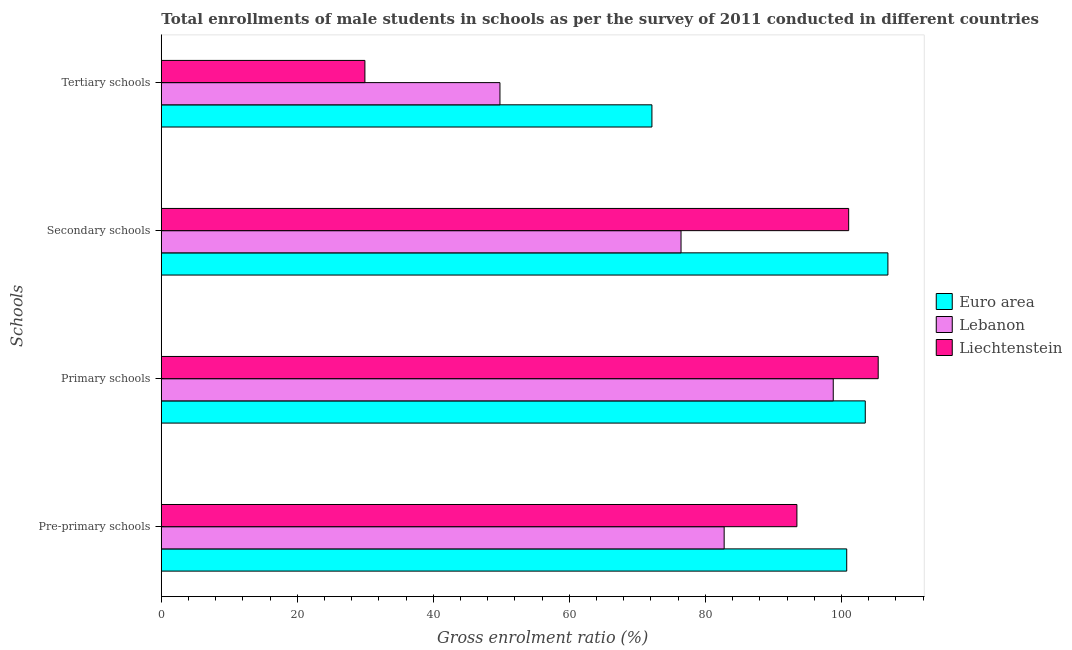How many bars are there on the 1st tick from the bottom?
Your response must be concise. 3. What is the label of the 3rd group of bars from the top?
Provide a succinct answer. Primary schools. What is the gross enrolment ratio(male) in pre-primary schools in Liechtenstein?
Provide a short and direct response. 93.46. Across all countries, what is the maximum gross enrolment ratio(male) in pre-primary schools?
Your answer should be very brief. 100.78. Across all countries, what is the minimum gross enrolment ratio(male) in secondary schools?
Ensure brevity in your answer.  76.42. In which country was the gross enrolment ratio(male) in secondary schools maximum?
Your response must be concise. Euro area. In which country was the gross enrolment ratio(male) in primary schools minimum?
Keep it short and to the point. Lebanon. What is the total gross enrolment ratio(male) in pre-primary schools in the graph?
Offer a terse response. 276.99. What is the difference between the gross enrolment ratio(male) in pre-primary schools in Liechtenstein and that in Euro area?
Your answer should be very brief. -7.32. What is the difference between the gross enrolment ratio(male) in pre-primary schools in Lebanon and the gross enrolment ratio(male) in primary schools in Euro area?
Give a very brief answer. -20.75. What is the average gross enrolment ratio(male) in secondary schools per country?
Your answer should be very brief. 94.77. What is the difference between the gross enrolment ratio(male) in tertiary schools and gross enrolment ratio(male) in pre-primary schools in Liechtenstein?
Your answer should be very brief. -63.52. What is the ratio of the gross enrolment ratio(male) in secondary schools in Euro area to that in Liechtenstein?
Keep it short and to the point. 1.06. Is the gross enrolment ratio(male) in pre-primary schools in Lebanon less than that in Liechtenstein?
Your answer should be very brief. Yes. What is the difference between the highest and the second highest gross enrolment ratio(male) in primary schools?
Your answer should be compact. 1.9. What is the difference between the highest and the lowest gross enrolment ratio(male) in pre-primary schools?
Offer a terse response. 18.02. In how many countries, is the gross enrolment ratio(male) in pre-primary schools greater than the average gross enrolment ratio(male) in pre-primary schools taken over all countries?
Your response must be concise. 2. What does the 1st bar from the top in Pre-primary schools represents?
Ensure brevity in your answer.  Liechtenstein. What does the 1st bar from the bottom in Primary schools represents?
Offer a terse response. Euro area. What is the difference between two consecutive major ticks on the X-axis?
Your response must be concise. 20. Does the graph contain any zero values?
Your answer should be very brief. No. Does the graph contain grids?
Offer a very short reply. No. What is the title of the graph?
Offer a terse response. Total enrollments of male students in schools as per the survey of 2011 conducted in different countries. What is the label or title of the Y-axis?
Make the answer very short. Schools. What is the Gross enrolment ratio (%) in Euro area in Pre-primary schools?
Your answer should be very brief. 100.78. What is the Gross enrolment ratio (%) in Lebanon in Pre-primary schools?
Keep it short and to the point. 82.76. What is the Gross enrolment ratio (%) of Liechtenstein in Pre-primary schools?
Offer a terse response. 93.46. What is the Gross enrolment ratio (%) in Euro area in Primary schools?
Provide a succinct answer. 103.51. What is the Gross enrolment ratio (%) of Lebanon in Primary schools?
Your answer should be compact. 98.8. What is the Gross enrolment ratio (%) of Liechtenstein in Primary schools?
Your answer should be very brief. 105.41. What is the Gross enrolment ratio (%) in Euro area in Secondary schools?
Make the answer very short. 106.84. What is the Gross enrolment ratio (%) of Lebanon in Secondary schools?
Your answer should be compact. 76.42. What is the Gross enrolment ratio (%) of Liechtenstein in Secondary schools?
Give a very brief answer. 101.07. What is the Gross enrolment ratio (%) of Euro area in Tertiary schools?
Keep it short and to the point. 72.14. What is the Gross enrolment ratio (%) in Lebanon in Tertiary schools?
Provide a succinct answer. 49.79. What is the Gross enrolment ratio (%) of Liechtenstein in Tertiary schools?
Offer a terse response. 29.94. Across all Schools, what is the maximum Gross enrolment ratio (%) of Euro area?
Keep it short and to the point. 106.84. Across all Schools, what is the maximum Gross enrolment ratio (%) of Lebanon?
Keep it short and to the point. 98.8. Across all Schools, what is the maximum Gross enrolment ratio (%) in Liechtenstein?
Offer a very short reply. 105.41. Across all Schools, what is the minimum Gross enrolment ratio (%) in Euro area?
Ensure brevity in your answer.  72.14. Across all Schools, what is the minimum Gross enrolment ratio (%) of Lebanon?
Keep it short and to the point. 49.79. Across all Schools, what is the minimum Gross enrolment ratio (%) in Liechtenstein?
Give a very brief answer. 29.94. What is the total Gross enrolment ratio (%) in Euro area in the graph?
Your answer should be compact. 383.26. What is the total Gross enrolment ratio (%) in Lebanon in the graph?
Ensure brevity in your answer.  307.77. What is the total Gross enrolment ratio (%) in Liechtenstein in the graph?
Give a very brief answer. 329.87. What is the difference between the Gross enrolment ratio (%) in Euro area in Pre-primary schools and that in Primary schools?
Keep it short and to the point. -2.73. What is the difference between the Gross enrolment ratio (%) of Lebanon in Pre-primary schools and that in Primary schools?
Offer a very short reply. -16.04. What is the difference between the Gross enrolment ratio (%) of Liechtenstein in Pre-primary schools and that in Primary schools?
Offer a very short reply. -11.95. What is the difference between the Gross enrolment ratio (%) of Euro area in Pre-primary schools and that in Secondary schools?
Provide a succinct answer. -6.06. What is the difference between the Gross enrolment ratio (%) of Lebanon in Pre-primary schools and that in Secondary schools?
Keep it short and to the point. 6.34. What is the difference between the Gross enrolment ratio (%) of Liechtenstein in Pre-primary schools and that in Secondary schools?
Your response must be concise. -7.61. What is the difference between the Gross enrolment ratio (%) of Euro area in Pre-primary schools and that in Tertiary schools?
Your answer should be compact. 28.64. What is the difference between the Gross enrolment ratio (%) in Lebanon in Pre-primary schools and that in Tertiary schools?
Ensure brevity in your answer.  32.97. What is the difference between the Gross enrolment ratio (%) of Liechtenstein in Pre-primary schools and that in Tertiary schools?
Your answer should be compact. 63.52. What is the difference between the Gross enrolment ratio (%) in Euro area in Primary schools and that in Secondary schools?
Keep it short and to the point. -3.33. What is the difference between the Gross enrolment ratio (%) of Lebanon in Primary schools and that in Secondary schools?
Offer a very short reply. 22.38. What is the difference between the Gross enrolment ratio (%) in Liechtenstein in Primary schools and that in Secondary schools?
Provide a succinct answer. 4.34. What is the difference between the Gross enrolment ratio (%) in Euro area in Primary schools and that in Tertiary schools?
Your response must be concise. 31.37. What is the difference between the Gross enrolment ratio (%) in Lebanon in Primary schools and that in Tertiary schools?
Provide a short and direct response. 49.01. What is the difference between the Gross enrolment ratio (%) in Liechtenstein in Primary schools and that in Tertiary schools?
Make the answer very short. 75.47. What is the difference between the Gross enrolment ratio (%) in Euro area in Secondary schools and that in Tertiary schools?
Provide a succinct answer. 34.7. What is the difference between the Gross enrolment ratio (%) in Lebanon in Secondary schools and that in Tertiary schools?
Offer a very short reply. 26.63. What is the difference between the Gross enrolment ratio (%) in Liechtenstein in Secondary schools and that in Tertiary schools?
Make the answer very short. 71.13. What is the difference between the Gross enrolment ratio (%) of Euro area in Pre-primary schools and the Gross enrolment ratio (%) of Lebanon in Primary schools?
Give a very brief answer. 1.98. What is the difference between the Gross enrolment ratio (%) in Euro area in Pre-primary schools and the Gross enrolment ratio (%) in Liechtenstein in Primary schools?
Provide a short and direct response. -4.63. What is the difference between the Gross enrolment ratio (%) of Lebanon in Pre-primary schools and the Gross enrolment ratio (%) of Liechtenstein in Primary schools?
Provide a succinct answer. -22.65. What is the difference between the Gross enrolment ratio (%) in Euro area in Pre-primary schools and the Gross enrolment ratio (%) in Lebanon in Secondary schools?
Ensure brevity in your answer.  24.36. What is the difference between the Gross enrolment ratio (%) in Euro area in Pre-primary schools and the Gross enrolment ratio (%) in Liechtenstein in Secondary schools?
Provide a short and direct response. -0.29. What is the difference between the Gross enrolment ratio (%) in Lebanon in Pre-primary schools and the Gross enrolment ratio (%) in Liechtenstein in Secondary schools?
Make the answer very short. -18.31. What is the difference between the Gross enrolment ratio (%) in Euro area in Pre-primary schools and the Gross enrolment ratio (%) in Lebanon in Tertiary schools?
Make the answer very short. 50.99. What is the difference between the Gross enrolment ratio (%) of Euro area in Pre-primary schools and the Gross enrolment ratio (%) of Liechtenstein in Tertiary schools?
Your answer should be compact. 70.84. What is the difference between the Gross enrolment ratio (%) in Lebanon in Pre-primary schools and the Gross enrolment ratio (%) in Liechtenstein in Tertiary schools?
Offer a very short reply. 52.82. What is the difference between the Gross enrolment ratio (%) of Euro area in Primary schools and the Gross enrolment ratio (%) of Lebanon in Secondary schools?
Provide a succinct answer. 27.09. What is the difference between the Gross enrolment ratio (%) of Euro area in Primary schools and the Gross enrolment ratio (%) of Liechtenstein in Secondary schools?
Give a very brief answer. 2.44. What is the difference between the Gross enrolment ratio (%) of Lebanon in Primary schools and the Gross enrolment ratio (%) of Liechtenstein in Secondary schools?
Make the answer very short. -2.27. What is the difference between the Gross enrolment ratio (%) in Euro area in Primary schools and the Gross enrolment ratio (%) in Lebanon in Tertiary schools?
Offer a very short reply. 53.72. What is the difference between the Gross enrolment ratio (%) in Euro area in Primary schools and the Gross enrolment ratio (%) in Liechtenstein in Tertiary schools?
Keep it short and to the point. 73.57. What is the difference between the Gross enrolment ratio (%) of Lebanon in Primary schools and the Gross enrolment ratio (%) of Liechtenstein in Tertiary schools?
Your answer should be very brief. 68.86. What is the difference between the Gross enrolment ratio (%) in Euro area in Secondary schools and the Gross enrolment ratio (%) in Lebanon in Tertiary schools?
Your answer should be compact. 57.05. What is the difference between the Gross enrolment ratio (%) of Euro area in Secondary schools and the Gross enrolment ratio (%) of Liechtenstein in Tertiary schools?
Keep it short and to the point. 76.9. What is the difference between the Gross enrolment ratio (%) of Lebanon in Secondary schools and the Gross enrolment ratio (%) of Liechtenstein in Tertiary schools?
Ensure brevity in your answer.  46.48. What is the average Gross enrolment ratio (%) in Euro area per Schools?
Keep it short and to the point. 95.81. What is the average Gross enrolment ratio (%) of Lebanon per Schools?
Offer a very short reply. 76.94. What is the average Gross enrolment ratio (%) in Liechtenstein per Schools?
Keep it short and to the point. 82.47. What is the difference between the Gross enrolment ratio (%) in Euro area and Gross enrolment ratio (%) in Lebanon in Pre-primary schools?
Provide a short and direct response. 18.02. What is the difference between the Gross enrolment ratio (%) of Euro area and Gross enrolment ratio (%) of Liechtenstein in Pre-primary schools?
Give a very brief answer. 7.32. What is the difference between the Gross enrolment ratio (%) of Lebanon and Gross enrolment ratio (%) of Liechtenstein in Pre-primary schools?
Your answer should be very brief. -10.7. What is the difference between the Gross enrolment ratio (%) of Euro area and Gross enrolment ratio (%) of Lebanon in Primary schools?
Provide a succinct answer. 4.71. What is the difference between the Gross enrolment ratio (%) of Euro area and Gross enrolment ratio (%) of Liechtenstein in Primary schools?
Ensure brevity in your answer.  -1.9. What is the difference between the Gross enrolment ratio (%) of Lebanon and Gross enrolment ratio (%) of Liechtenstein in Primary schools?
Make the answer very short. -6.61. What is the difference between the Gross enrolment ratio (%) in Euro area and Gross enrolment ratio (%) in Lebanon in Secondary schools?
Your response must be concise. 30.42. What is the difference between the Gross enrolment ratio (%) of Euro area and Gross enrolment ratio (%) of Liechtenstein in Secondary schools?
Give a very brief answer. 5.77. What is the difference between the Gross enrolment ratio (%) in Lebanon and Gross enrolment ratio (%) in Liechtenstein in Secondary schools?
Provide a short and direct response. -24.65. What is the difference between the Gross enrolment ratio (%) of Euro area and Gross enrolment ratio (%) of Lebanon in Tertiary schools?
Your answer should be very brief. 22.35. What is the difference between the Gross enrolment ratio (%) in Euro area and Gross enrolment ratio (%) in Liechtenstein in Tertiary schools?
Your response must be concise. 42.2. What is the difference between the Gross enrolment ratio (%) of Lebanon and Gross enrolment ratio (%) of Liechtenstein in Tertiary schools?
Provide a short and direct response. 19.86. What is the ratio of the Gross enrolment ratio (%) of Euro area in Pre-primary schools to that in Primary schools?
Provide a short and direct response. 0.97. What is the ratio of the Gross enrolment ratio (%) of Lebanon in Pre-primary schools to that in Primary schools?
Offer a terse response. 0.84. What is the ratio of the Gross enrolment ratio (%) in Liechtenstein in Pre-primary schools to that in Primary schools?
Provide a succinct answer. 0.89. What is the ratio of the Gross enrolment ratio (%) in Euro area in Pre-primary schools to that in Secondary schools?
Give a very brief answer. 0.94. What is the ratio of the Gross enrolment ratio (%) in Lebanon in Pre-primary schools to that in Secondary schools?
Provide a succinct answer. 1.08. What is the ratio of the Gross enrolment ratio (%) in Liechtenstein in Pre-primary schools to that in Secondary schools?
Give a very brief answer. 0.92. What is the ratio of the Gross enrolment ratio (%) in Euro area in Pre-primary schools to that in Tertiary schools?
Provide a succinct answer. 1.4. What is the ratio of the Gross enrolment ratio (%) of Lebanon in Pre-primary schools to that in Tertiary schools?
Provide a succinct answer. 1.66. What is the ratio of the Gross enrolment ratio (%) in Liechtenstein in Pre-primary schools to that in Tertiary schools?
Make the answer very short. 3.12. What is the ratio of the Gross enrolment ratio (%) of Euro area in Primary schools to that in Secondary schools?
Offer a very short reply. 0.97. What is the ratio of the Gross enrolment ratio (%) of Lebanon in Primary schools to that in Secondary schools?
Make the answer very short. 1.29. What is the ratio of the Gross enrolment ratio (%) of Liechtenstein in Primary schools to that in Secondary schools?
Provide a short and direct response. 1.04. What is the ratio of the Gross enrolment ratio (%) of Euro area in Primary schools to that in Tertiary schools?
Offer a very short reply. 1.43. What is the ratio of the Gross enrolment ratio (%) in Lebanon in Primary schools to that in Tertiary schools?
Give a very brief answer. 1.98. What is the ratio of the Gross enrolment ratio (%) in Liechtenstein in Primary schools to that in Tertiary schools?
Your response must be concise. 3.52. What is the ratio of the Gross enrolment ratio (%) in Euro area in Secondary schools to that in Tertiary schools?
Provide a short and direct response. 1.48. What is the ratio of the Gross enrolment ratio (%) in Lebanon in Secondary schools to that in Tertiary schools?
Ensure brevity in your answer.  1.53. What is the ratio of the Gross enrolment ratio (%) of Liechtenstein in Secondary schools to that in Tertiary schools?
Your response must be concise. 3.38. What is the difference between the highest and the second highest Gross enrolment ratio (%) in Euro area?
Your answer should be very brief. 3.33. What is the difference between the highest and the second highest Gross enrolment ratio (%) of Lebanon?
Make the answer very short. 16.04. What is the difference between the highest and the second highest Gross enrolment ratio (%) in Liechtenstein?
Your response must be concise. 4.34. What is the difference between the highest and the lowest Gross enrolment ratio (%) in Euro area?
Offer a terse response. 34.7. What is the difference between the highest and the lowest Gross enrolment ratio (%) of Lebanon?
Your answer should be very brief. 49.01. What is the difference between the highest and the lowest Gross enrolment ratio (%) of Liechtenstein?
Your answer should be compact. 75.47. 